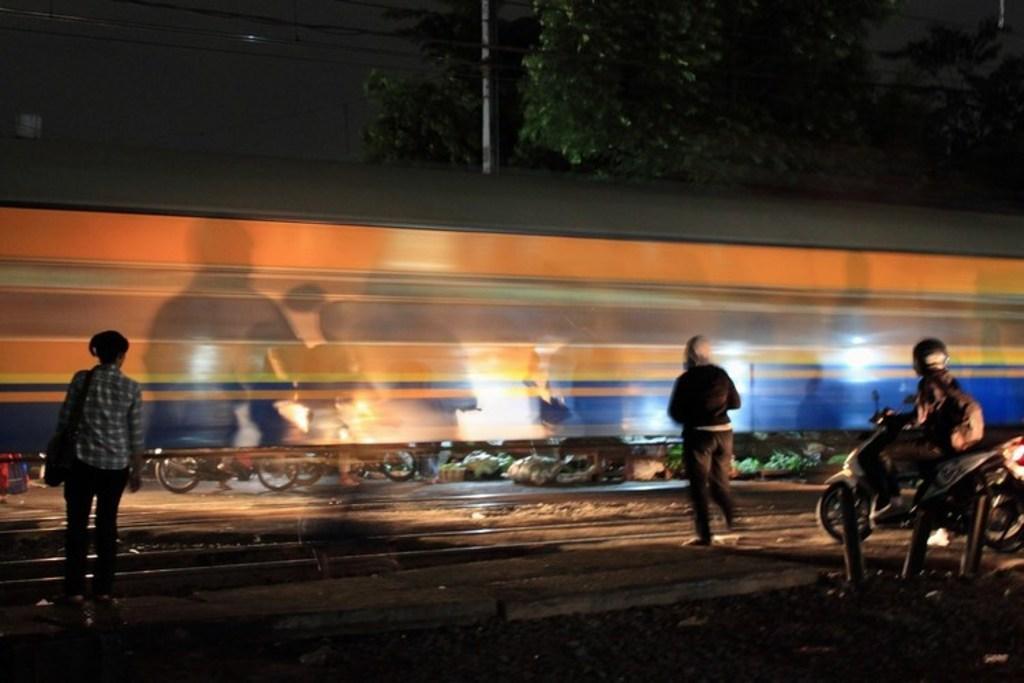Describe this image in one or two sentences. In this image on the right side there is one person who is sitting on a bike and riding. On the left side there is one woman who is standing and in the middle of the image there is one person who is walking. On the top of the image there is some trees and in the middle of the image there is one pole and on the left side there are some wires. In the middle of the image there is one screen and bikes are there and on the right side of the image there are some vegetables are there and in the bottom of the image there is some sand. 